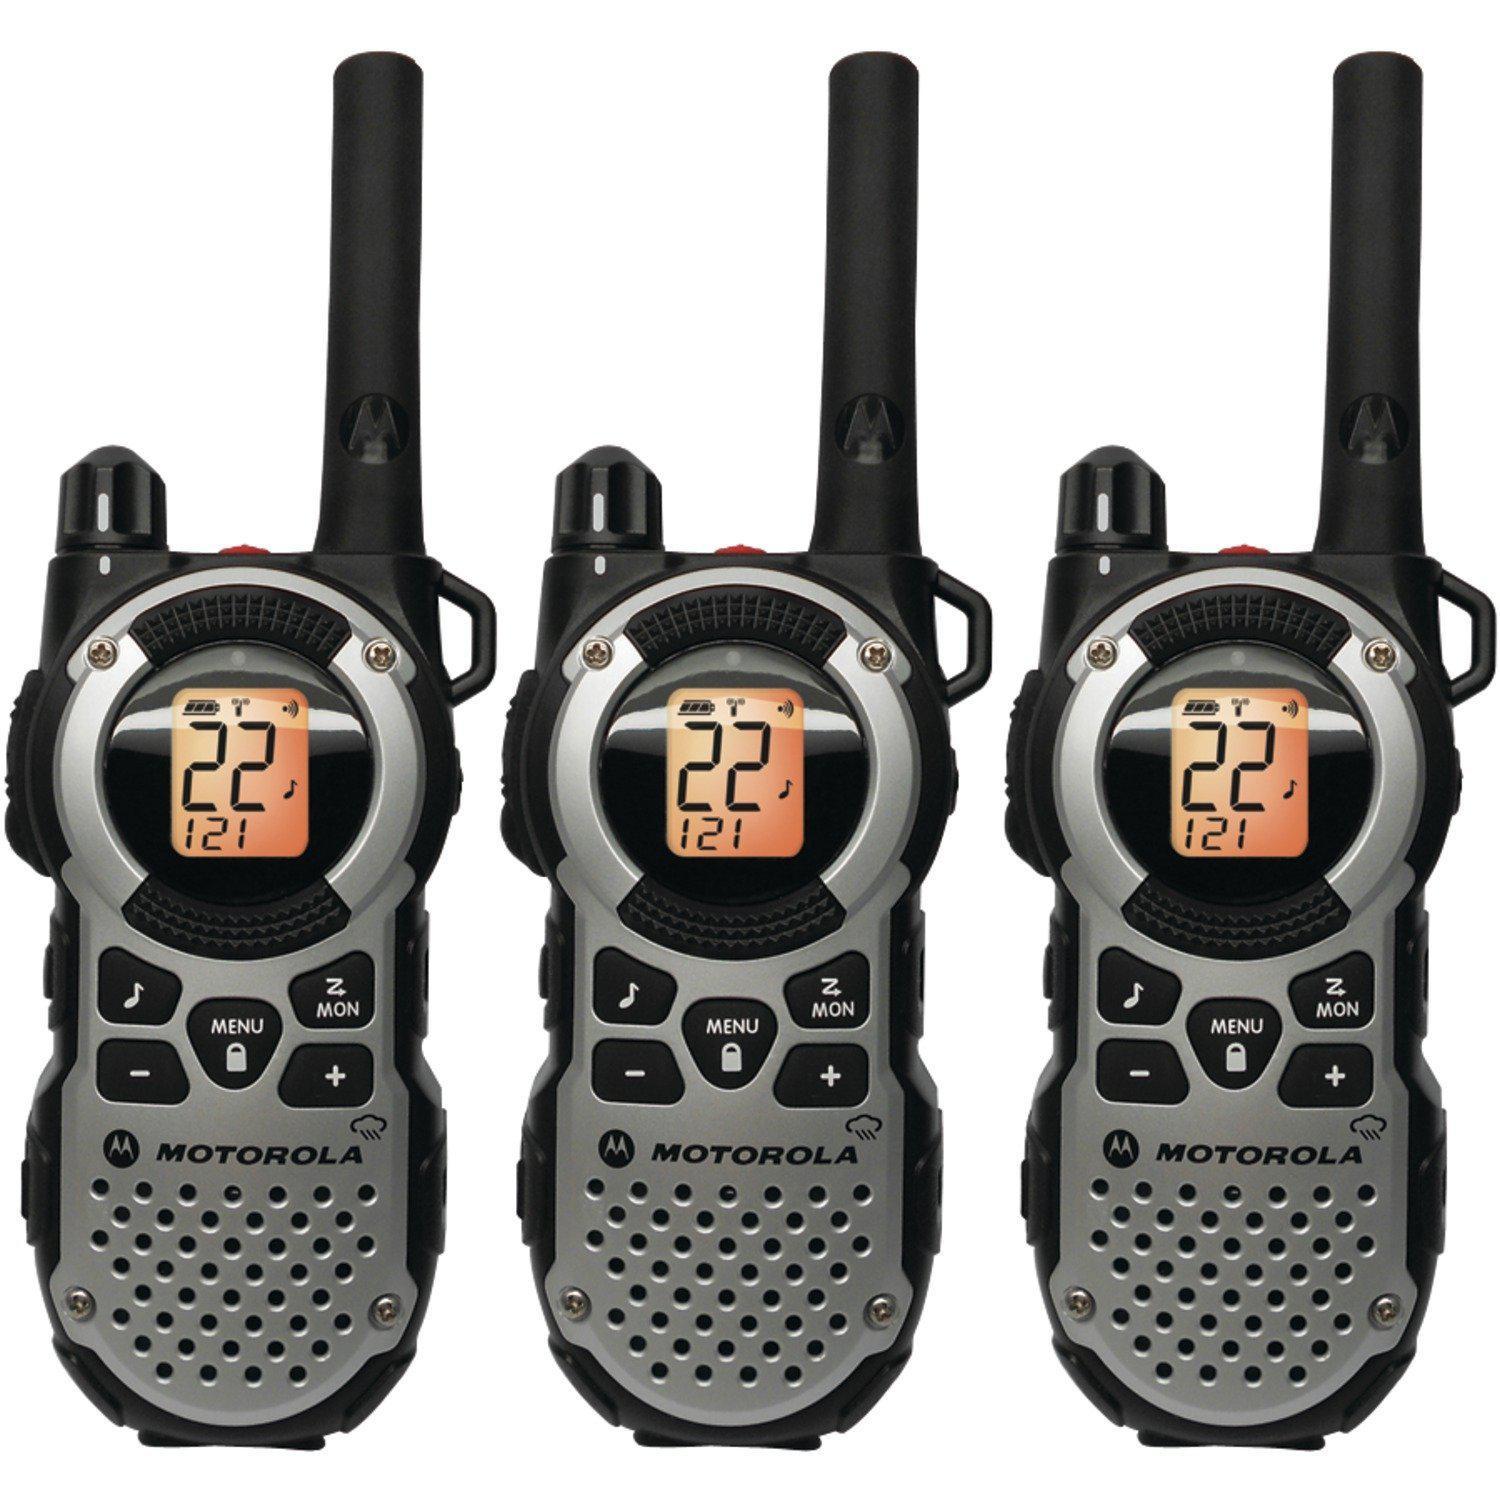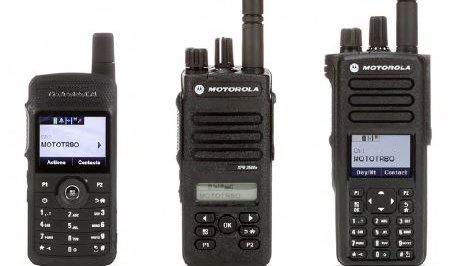The first image is the image on the left, the second image is the image on the right. Analyze the images presented: Is the assertion "At least 3 walkie-talkies are lined up next to each other in each picture." valid? Answer yes or no. Yes. The first image is the image on the left, the second image is the image on the right. Evaluate the accuracy of this statement regarding the images: "There are three walkie talkies.". Is it true? Answer yes or no. No. 